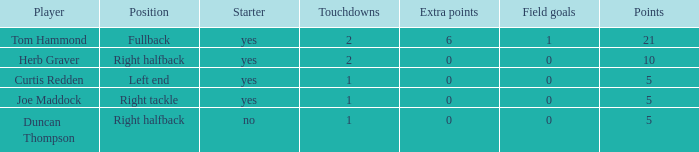Name the starter for position being left end Yes. 